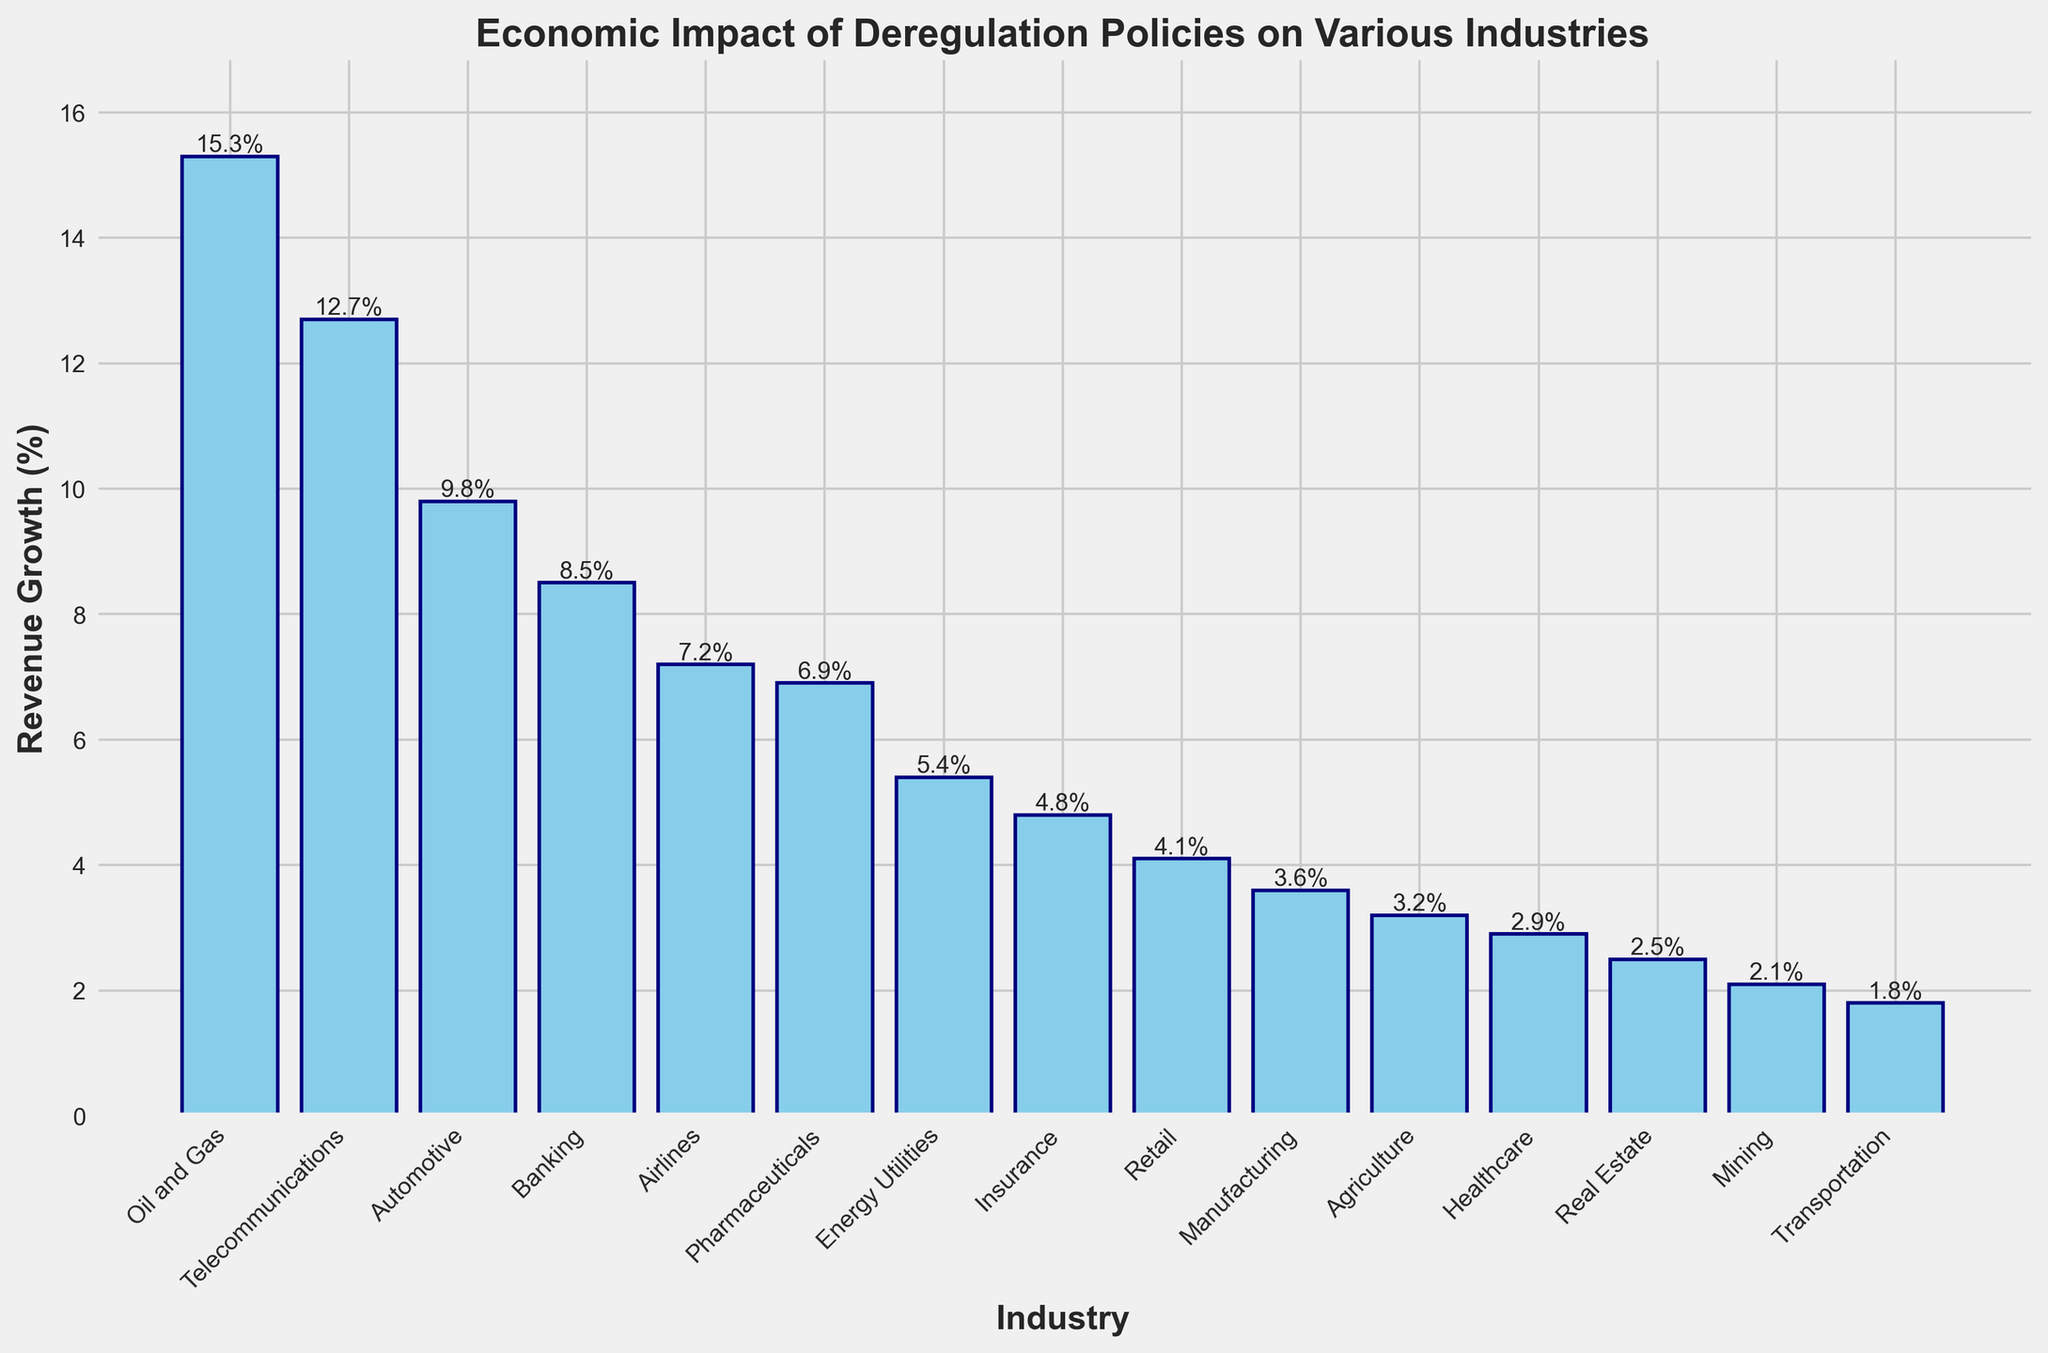Which industry has the highest revenue growth? Looking at the bar chart, the tallest bar represents the industry with the highest revenue growth. In this case, it is the Oil and Gas industry.
Answer: Oil and Gas What is the revenue growth percentage of the Telecommunications industry? Refer to the bar for Telecommunications, which shows the revenue growth percentage at the top. The value is 12.7%.
Answer: 12.7% How much greater is the revenue growth in the Automotive industry compared to the Retail industry? Subtract the revenue growth percentage of the Retail industry (4.1%) from that of the Automotive industry (9.8%). The difference is 9.8% - 4.1% = 5.7%.
Answer: 5.7% Which industries have revenue growth percentages below 5%? Identify all bars with heights less than the 5% mark. These are Manufacturing (3.6%), Agriculture (3.2%), Healthcare (2.9%), Real Estate (2.5%), Mining (2.1%), and Transportation (1.8%).
Answer: Manufacturing, Agriculture, Healthcare, Real Estate, Mining, Transportation What is the combined revenue growth percentage of the Banking and Insurance industries? Add the revenue growth percentages of Banking (8.5%) and Insurance (4.8%). The sum is 8.5% + 4.8% = 13.3%.
Answer: 13.3% What is the average revenue growth percentage for the top three industries? The top three industries are Oil and Gas (15.3%), Telecommunications (12.7%), and Automotive (9.8%). Calculate the average: (15.3% + 12.7% + 9.8%) / 3 = 12.6%.
Answer: 12.6% Is the revenue growth in the Healthcare industry higher or lower than in Real Estate? Compare the heights of the bars representing Healthcare (2.9%) and Real Estate (2.5%). Healthcare is higher.
Answer: Higher How many industries have a revenue growth percentage greater than 10%? Count the number of bars with heights above the 10% line. These are Oil and Gas (15.3%) and Telecommunications (12.7%). There are 2 such industries.
Answer: 2 Rank the industries with the three lowest revenue growth percentages. Identify the three industries with the smallest bars. These are Transportation (1.8%), Mining (2.1%), and Real Estate (2.5%), in ascending order.
Answer: Transportation, Mining, Real Estate What's the difference in revenue growth between the highest and lowest performing industries? Subtract the growth percentage of the lowest performing industry (Transportation, 1.8%) from that of the highest performing industry (Oil and Gas, 15.3%). The difference is 15.3% - 1.8% = 13.5%.
Answer: 13.5% 